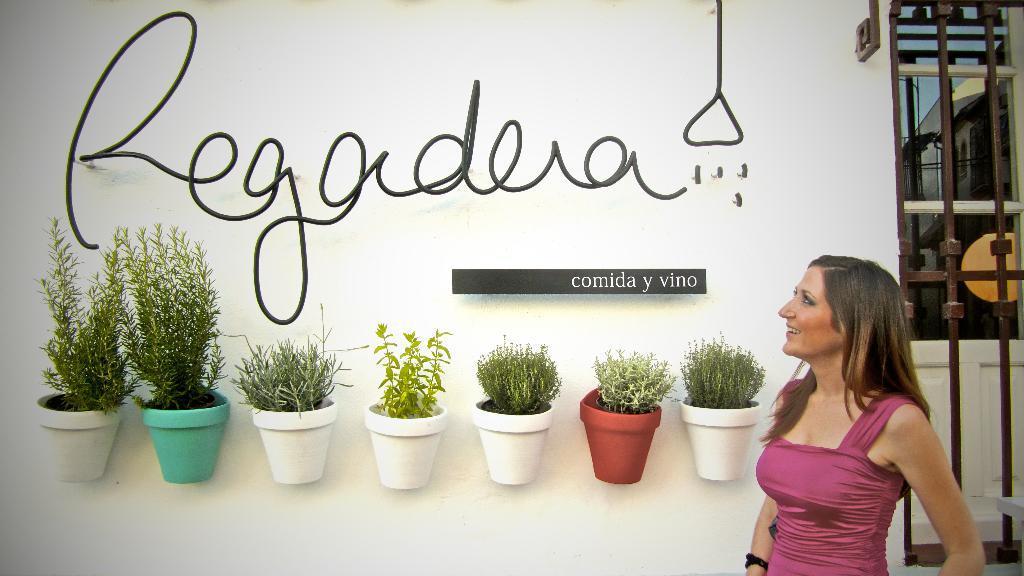Can you describe this image briefly? In this picture we can see a woman smiling, flower pots, rods and in the background we can see buildings, sky. 